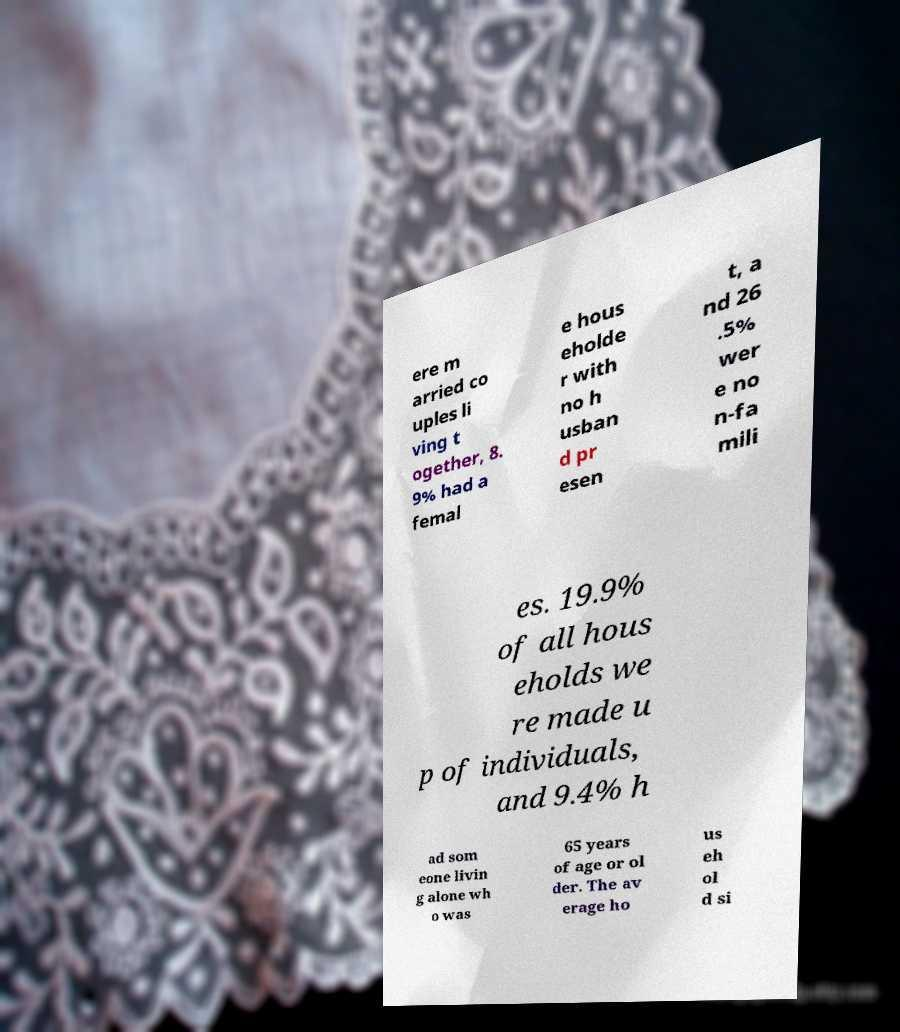There's text embedded in this image that I need extracted. Can you transcribe it verbatim? ere m arried co uples li ving t ogether, 8. 9% had a femal e hous eholde r with no h usban d pr esen t, a nd 26 .5% wer e no n-fa mili es. 19.9% of all hous eholds we re made u p of individuals, and 9.4% h ad som eone livin g alone wh o was 65 years of age or ol der. The av erage ho us eh ol d si 